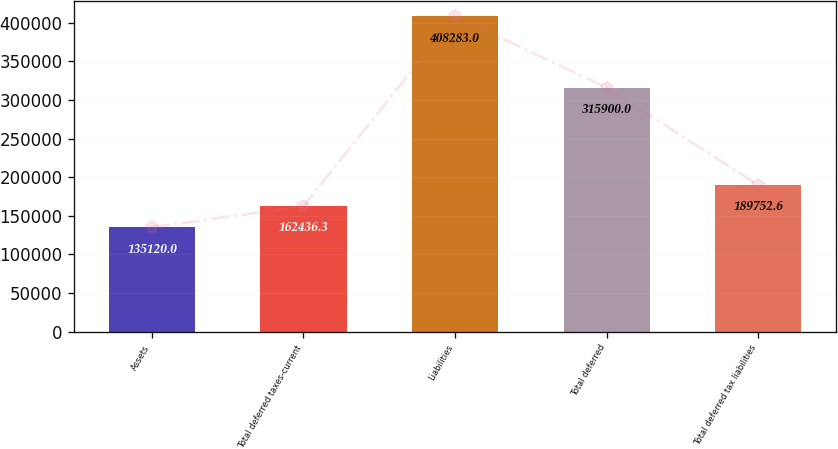Convert chart. <chart><loc_0><loc_0><loc_500><loc_500><bar_chart><fcel>Assets<fcel>Total deferred taxes-current<fcel>Liabilities<fcel>Total deferred<fcel>Total deferred tax liabilities<nl><fcel>135120<fcel>162436<fcel>408283<fcel>315900<fcel>189753<nl></chart> 